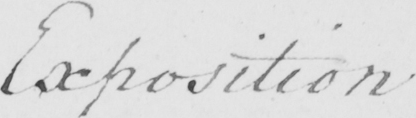What is written in this line of handwriting? Exposition 